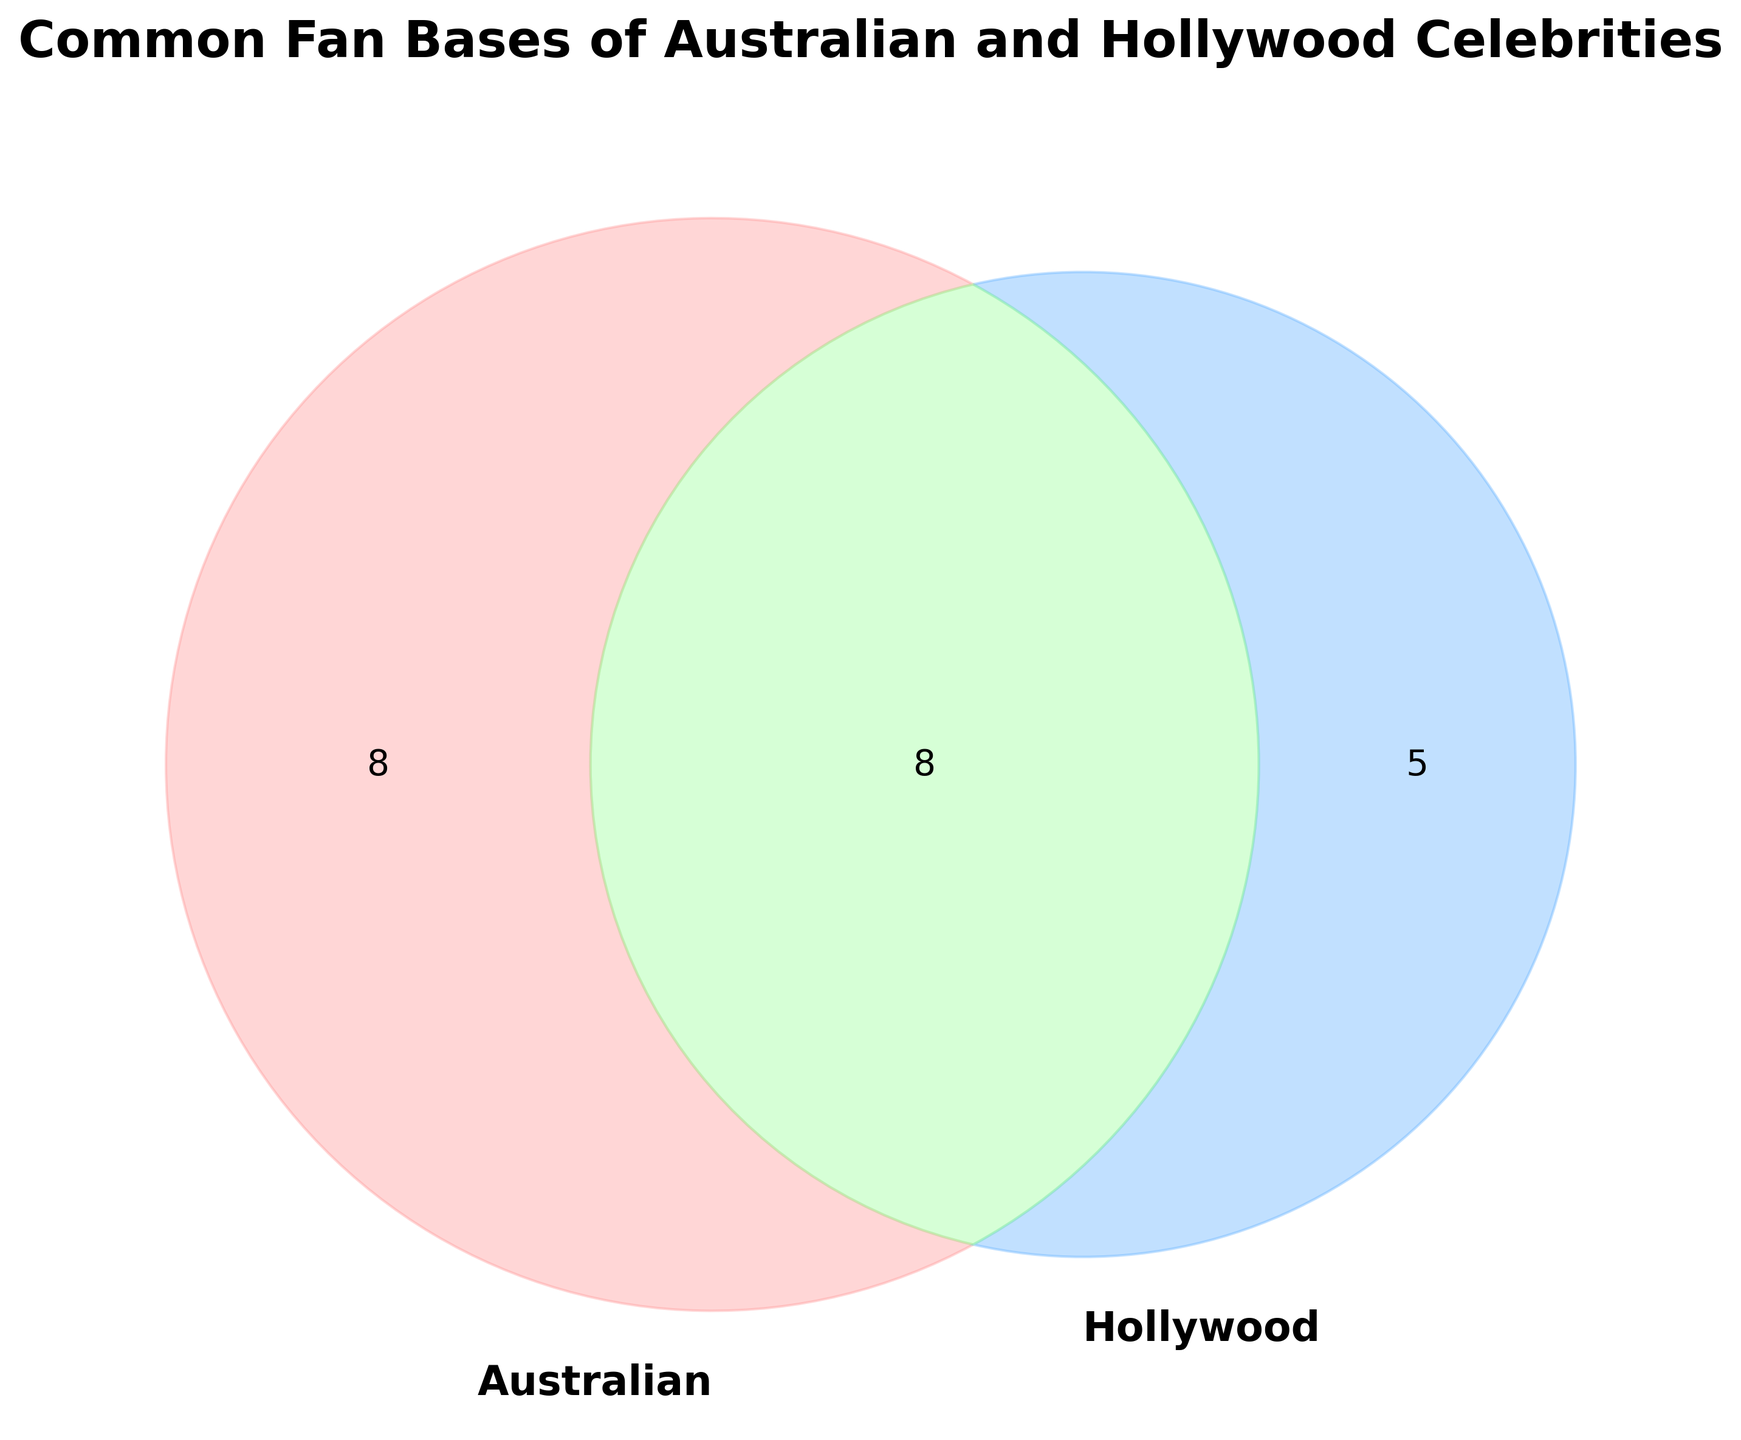How many celebrities fall into the 'Australian' category only? Look at the section of the Venn diagram labeled 'Australian' only and identify the number in that section.
Answer: 3 What is the title of the figure? The title is usually displayed at the top of a figure.
Answer: Common Fan Bases of Australian and Hollywood Celebrities What's the total number of celebrities represented in the Venn Diagram? Sum the numbers from all sections of the Venn diagram: 'Australian' only, 'Hollywood' only, and 'Both'.
Answer: 13 Which color represents the celebrities who are popular in both Australian and Hollywood categories? Identify the color of the overlapping section in the Venn diagram where both circles intersect.
Answer: Light green How many celebrities are there exclusively in the 'Hollywood' fan base? Look at the section of the Venn diagram labeled 'Hollywood' only and identify the number in that section.
Answer: 6 Is the number of celebrities in the 'Both' category greater than those in the 'Australian' only category? Compare the number in the 'Both' section with the number in the 'Australian' only section.
Answer: Yes What is the sum of celebrities in 'Both' and 'Australian' only categories? Add the numbers in the 'Both' and 'Australian' only sections of the Venn diagram: (9 + 3).
Answer: 9 How does the number of celebrities in the 'Both' category compare to those in 'Hollywood' only? Compare the values in the 'Both' and 'Hollywood' only sections of the Venn diagram.
Answer: Greater What is the ratio of 'Australian' only celebrities to 'Hollywood' only celebrities? Divide the number in the 'Australian' only section by the number in the 'Hollywood' only section: (3 / 6).
Answer: 1:2 Which section has the largest number of celebrities? Compare the numbers in all three sections and identify the largest.
Answer: Both 